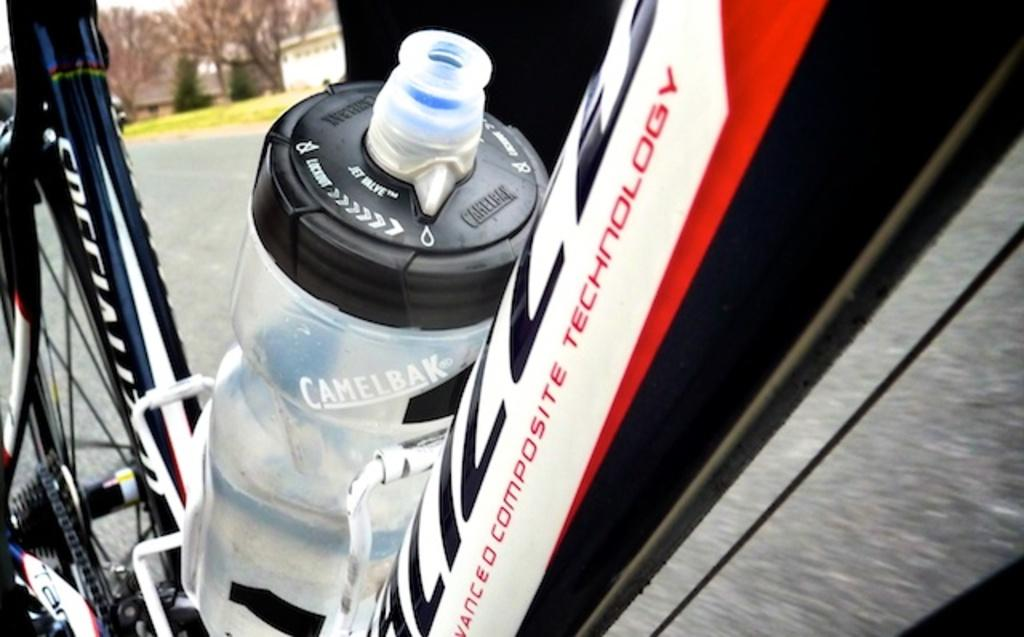What is the main object in the image? There is a bicycle in the image. Can you describe another object in the image? There is a bottle in the middle of the image. What type of insurance is being advertised on the bicycle in the image? There is no insurance or advertisement present on the bicycle in the image. How many pieces of popcorn are on the bicycle in the image? There is no popcorn present on the bicycle in the image. 